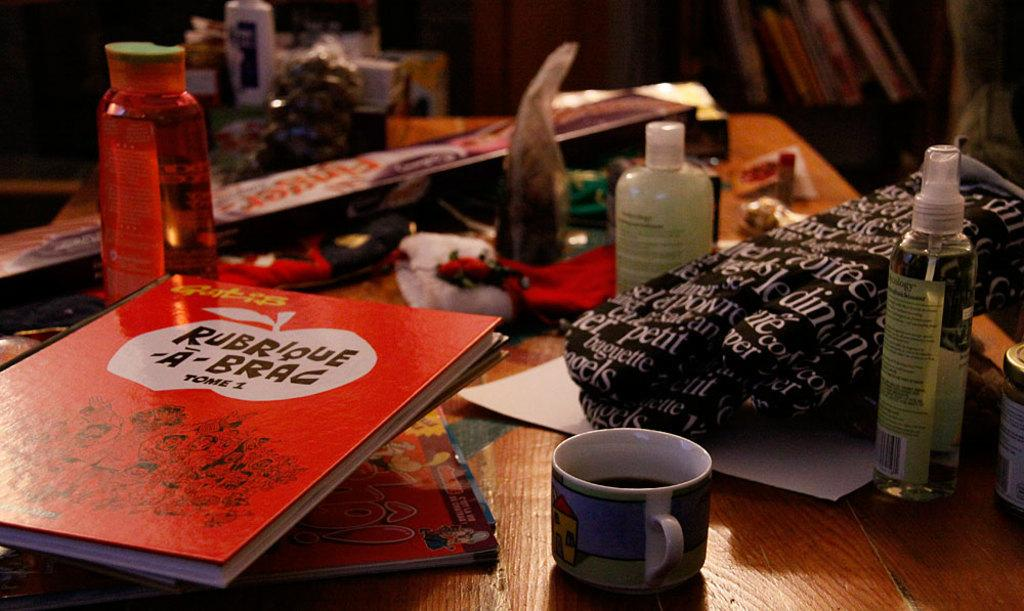Provide a one-sentence caption for the provided image. a cluttered desk with a red book titled "Rubrique a-brac". 